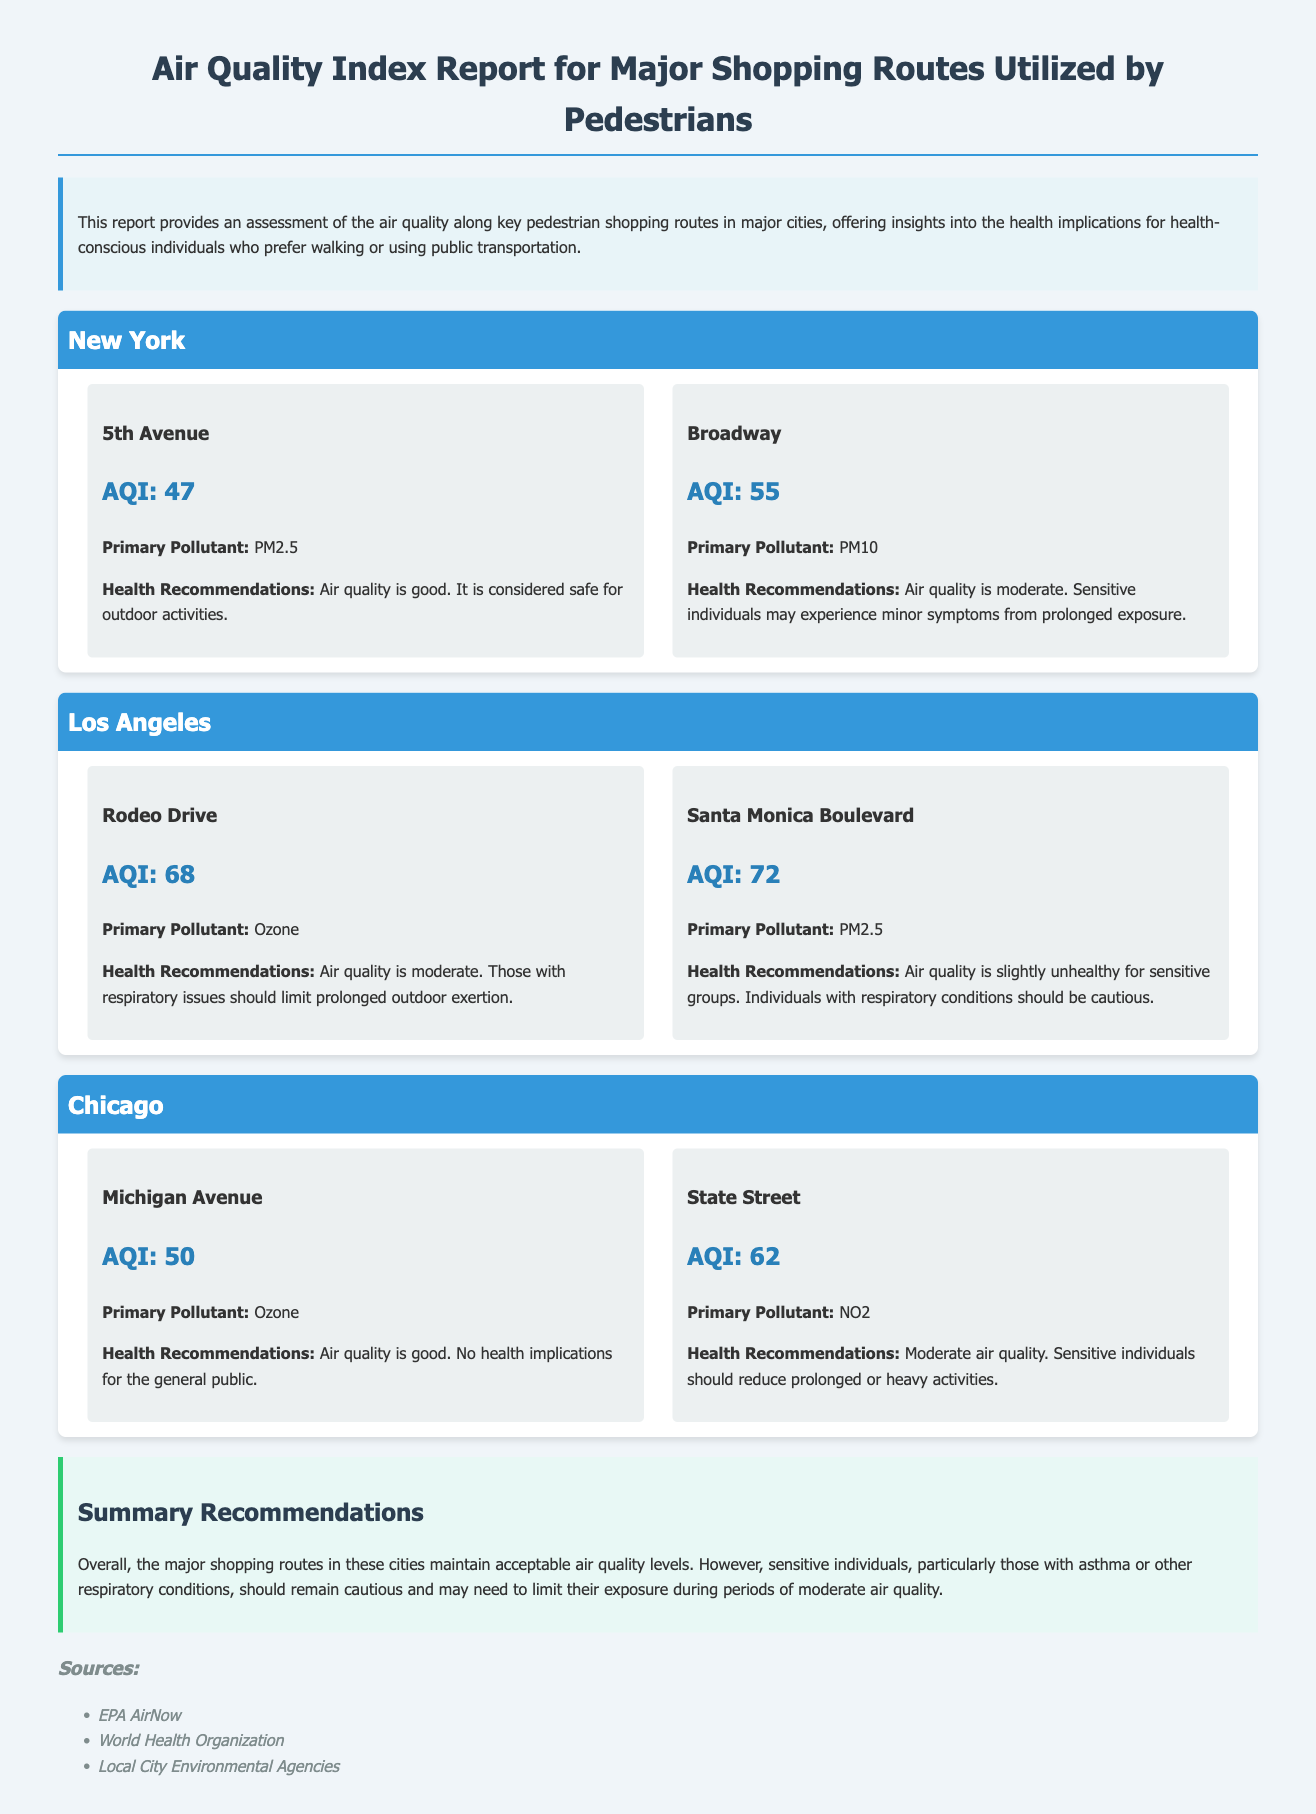what is the AQI for 5th Avenue? The AQI for 5th Avenue is provided in the document as part of the route details in New York.
Answer: 47 what is the primary pollutant along Rodeo Drive? The primary pollutant for Rodeo Drive is specified in the air quality report for Los Angeles.
Answer: Ozone what health recommendations are given for Santa Monica Boulevard? The health recommendations for Santa Monica Boulevard are noted under its air quality assessment in Los Angeles.
Answer: Slightly unhealthy for sensitive groups which city has a healthier AQI overall? This requires comparing the AQI values across the cities presented in the document.
Answer: New York what is the AQI range categorized as "moderate"? The document provides specific AQI values categorized as "moderate," which can be identified from the health recommendations.
Answer: 51-100 how many routes are reported for Chicago? The document lists the number of routes assessed for the city of Chicago in its air quality section.
Answer: 2 which route in New York has the highest AQI? This question requires comparing the AQI values for routes listed in New York to identify the highest.
Answer: Broadway what is the overall air quality level characterized as good? The document identifies specific routes and their respective AQI values classified as good, requiring retrieval from the content.
Answer: AQI: 0-50 which source is listed for air quality data? The sources of data are provided at the end of the document, containing the organizations used.
Answer: EPA AirNow 